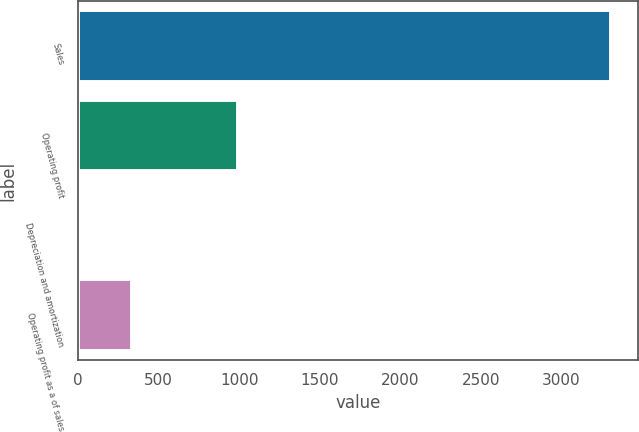Convert chart. <chart><loc_0><loc_0><loc_500><loc_500><bar_chart><fcel>Sales<fcel>Operating profit<fcel>Depreciation and amortization<fcel>Operating profit as a of sales<nl><fcel>3307.9<fcel>994.05<fcel>2.4<fcel>332.95<nl></chart> 